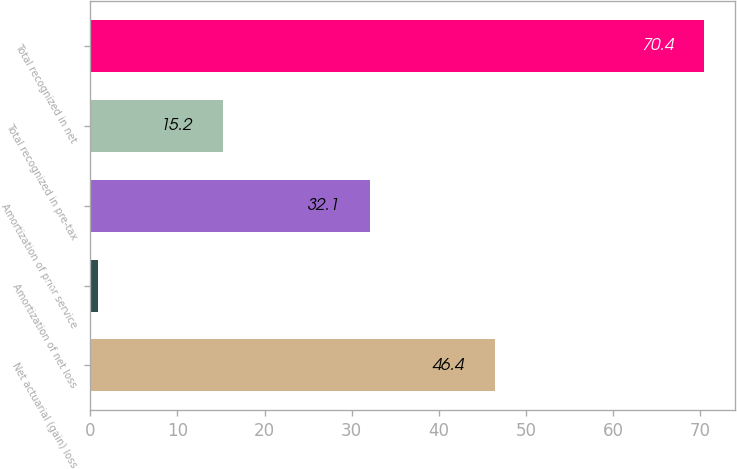Convert chart. <chart><loc_0><loc_0><loc_500><loc_500><bar_chart><fcel>Net actuarial (gain) loss<fcel>Amortization of net loss<fcel>Amortization of prior service<fcel>Total recognized in pre-tax<fcel>Total recognized in net<nl><fcel>46.4<fcel>0.9<fcel>32.1<fcel>15.2<fcel>70.4<nl></chart> 